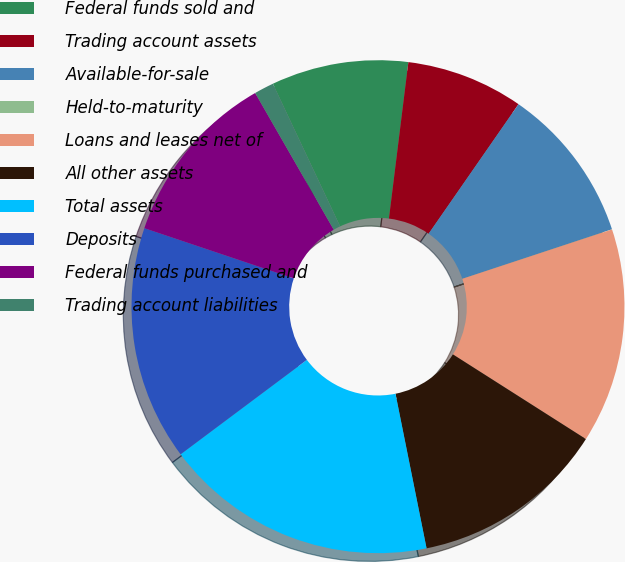Convert chart to OTSL. <chart><loc_0><loc_0><loc_500><loc_500><pie_chart><fcel>Federal funds sold and<fcel>Trading account assets<fcel>Available-for-sale<fcel>Held-to-maturity<fcel>Loans and leases net of<fcel>All other assets<fcel>Total assets<fcel>Deposits<fcel>Federal funds purchased and<fcel>Trading account liabilities<nl><fcel>8.98%<fcel>7.69%<fcel>10.26%<fcel>0.01%<fcel>14.1%<fcel>12.82%<fcel>17.94%<fcel>15.38%<fcel>11.54%<fcel>1.29%<nl></chart> 